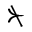<formula> <loc_0><loc_0><loc_500><loc_500>\nsucc</formula> 